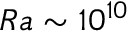<formula> <loc_0><loc_0><loc_500><loc_500>R a \sim 1 0 ^ { 1 0 }</formula> 